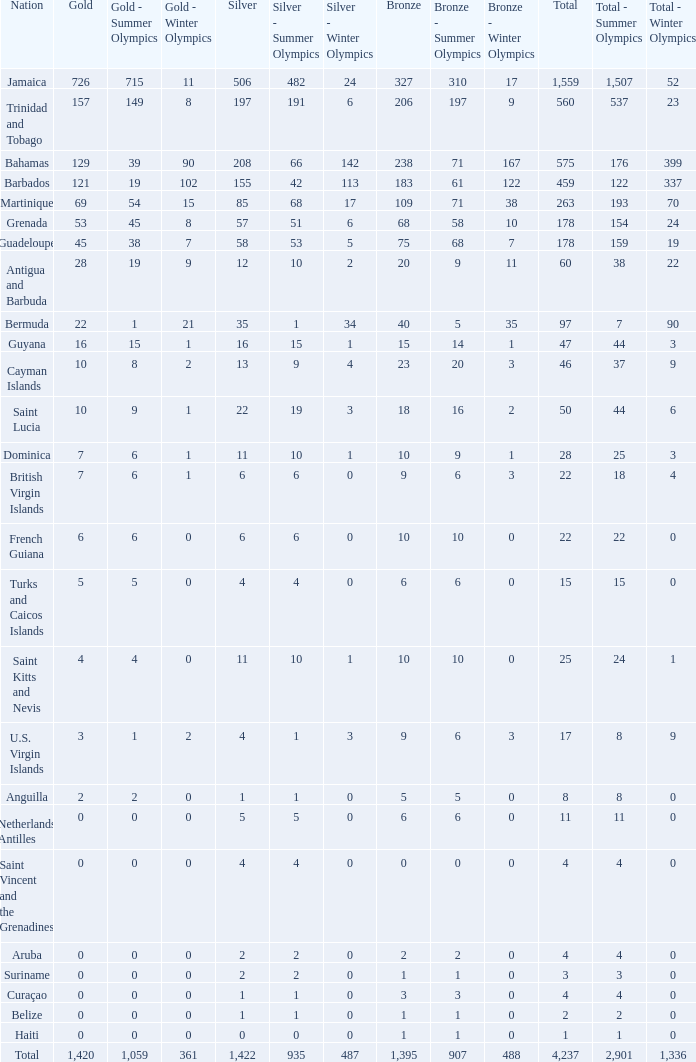What's the sum of Silver with total smaller than 560, a Bronze larger than 6, and a Gold of 3? 4.0. 